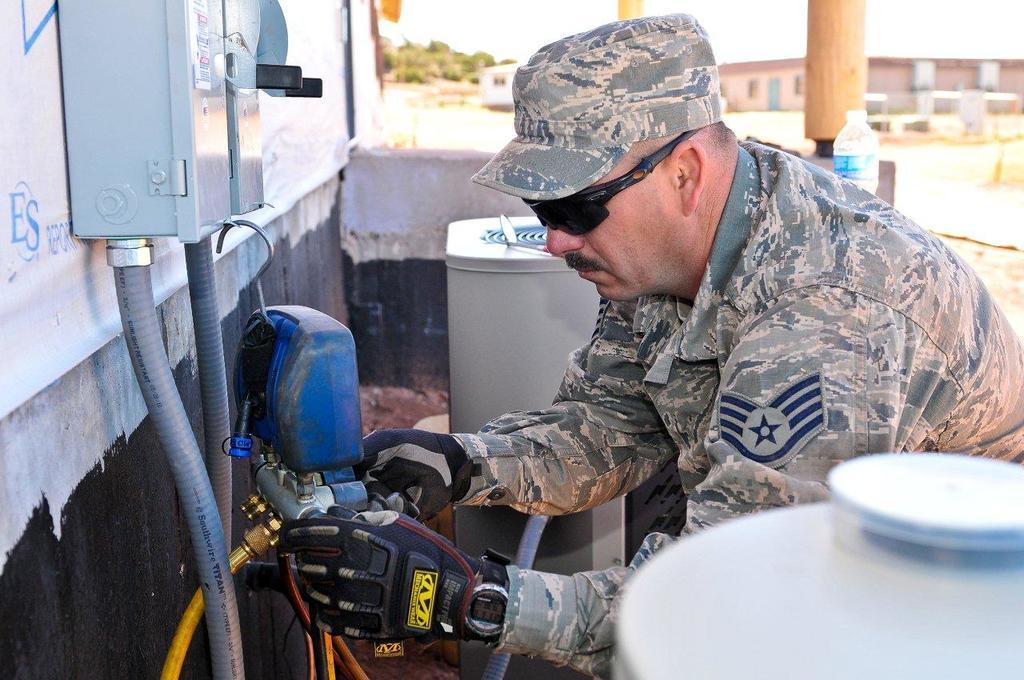Can you describe this image briefly? In this image we can see a person wearing cap, glasses, uniform, watch and gloves is holding and object. Here we can see pipes, some objects, water bottle and the background of the image is blurred, where we can see buildings, trees and the sky. 